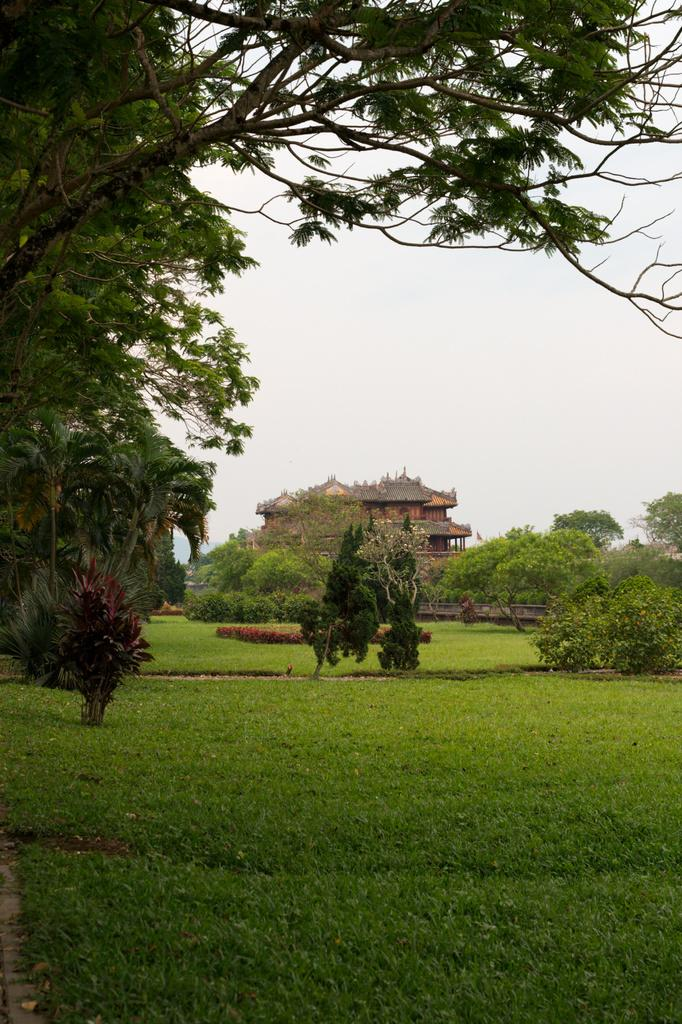What type of terrain is visible in the foreground of the image? There is grassland in the foreground of the image. What other types of vegetation can be seen in the image? There are plants and trees in the image. What type of structure is present in the image? There is a building in the image. What part of the natural environment is visible in the image? The sky is visible in the image. What type of poisonous furniture can be seen in the image? There is no furniture present in the image, let alone poisonous furniture. 